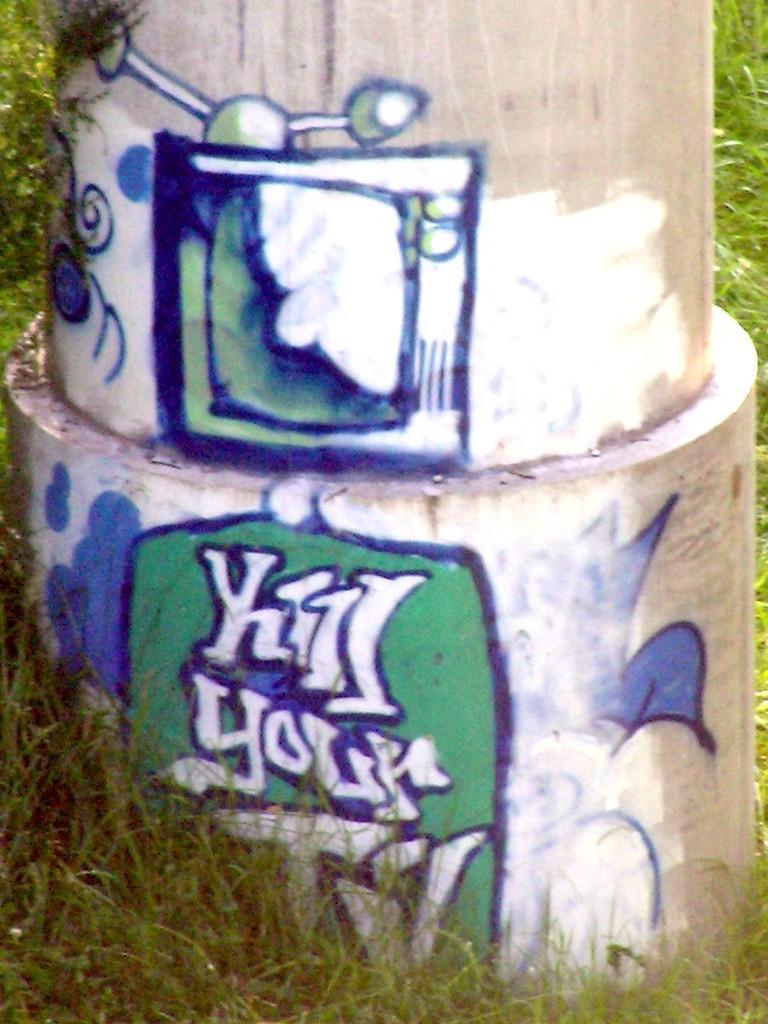Describe this image in one or two sentences. In this image there is a pillar on which there is painting. At the bottom there is grass. 